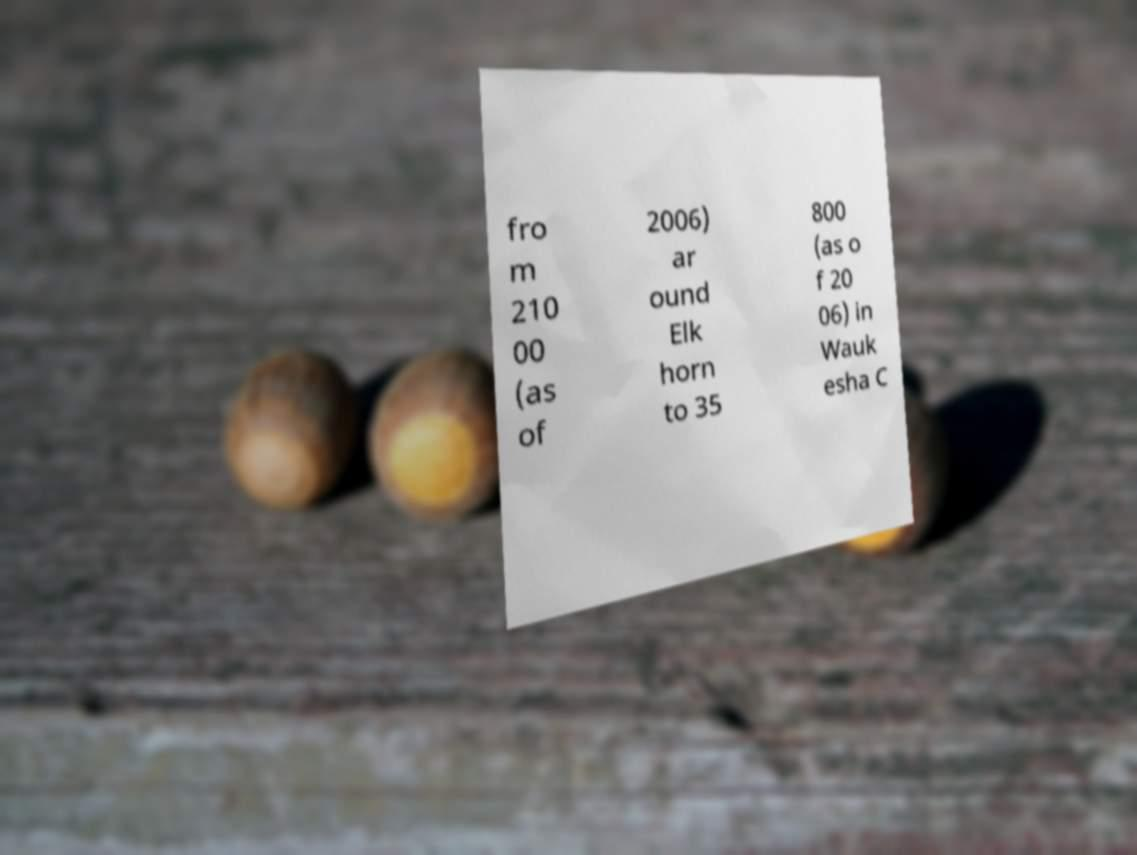Please identify and transcribe the text found in this image. fro m 210 00 (as of 2006) ar ound Elk horn to 35 800 (as o f 20 06) in Wauk esha C 